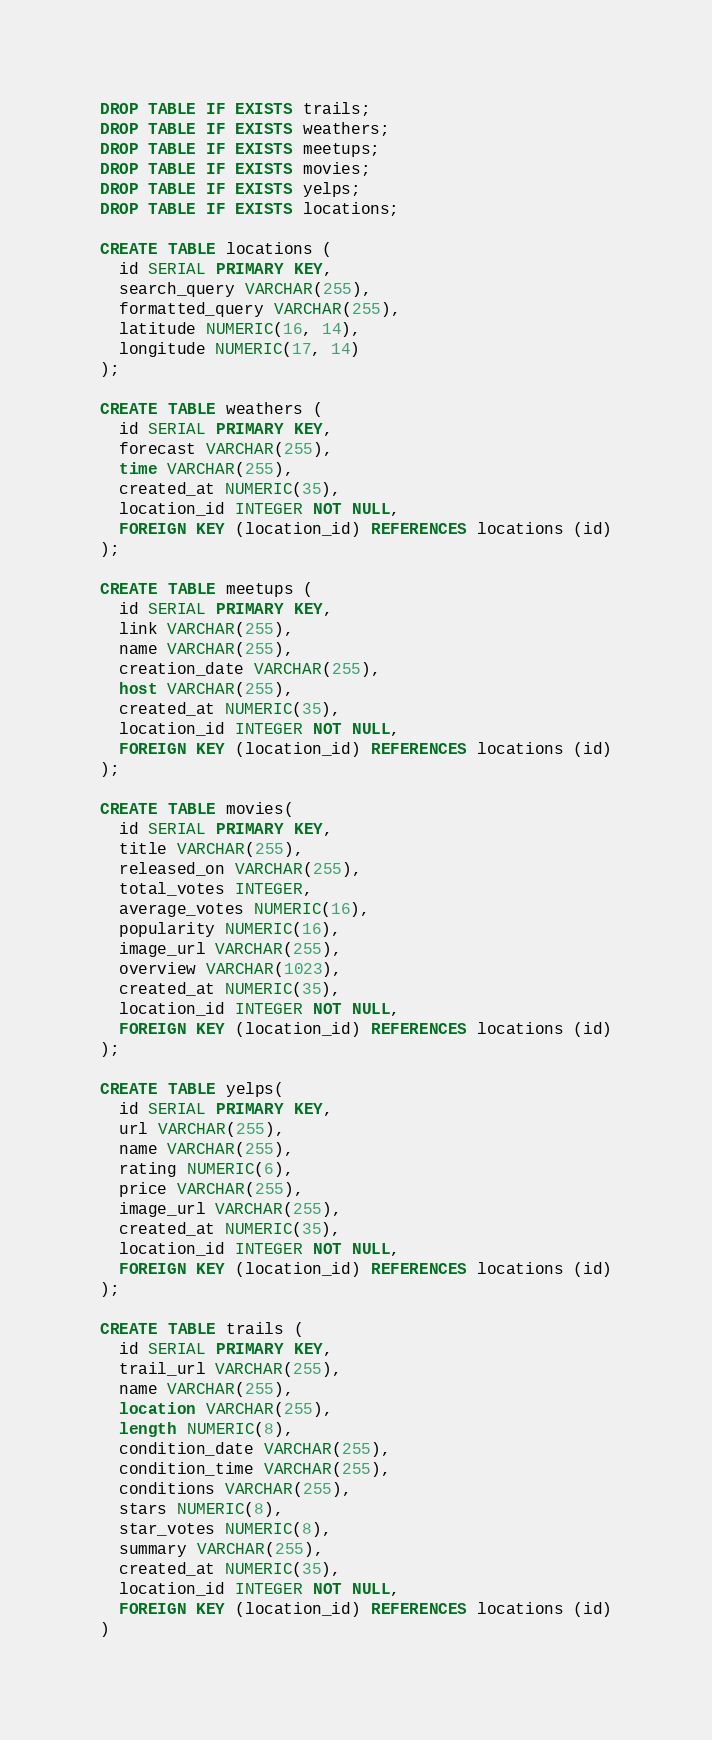Convert code to text. <code><loc_0><loc_0><loc_500><loc_500><_SQL_>DROP TABLE IF EXISTS trails;
DROP TABLE IF EXISTS weathers;
DROP TABLE IF EXISTS meetups;
DROP TABLE IF EXISTS movies;
DROP TABLE IF EXISTS yelps;
DROP TABLE IF EXISTS locations;

CREATE TABLE locations (
  id SERIAL PRIMARY KEY,
  search_query VARCHAR(255),
  formatted_query VARCHAR(255),
  latitude NUMERIC(16, 14),
  longitude NUMERIC(17, 14)
);

CREATE TABLE weathers (
  id SERIAL PRIMARY KEY,
  forecast VARCHAR(255),
  time VARCHAR(255),
  created_at NUMERIC(35),
  location_id INTEGER NOT NULL,
  FOREIGN KEY (location_id) REFERENCES locations (id)
);

CREATE TABLE meetups (
  id SERIAL PRIMARY KEY,
  link VARCHAR(255),
  name VARCHAR(255),
  creation_date VARCHAR(255),
  host VARCHAR(255),
  created_at NUMERIC(35),
  location_id INTEGER NOT NULL,
  FOREIGN KEY (location_id) REFERENCES locations (id)
);

CREATE TABLE movies(
  id SERIAL PRIMARY KEY,
  title VARCHAR(255),
  released_on VARCHAR(255),
  total_votes INTEGER,
  average_votes NUMERIC(16),
  popularity NUMERIC(16),
  image_url VARCHAR(255),
  overview VARCHAR(1023),
  created_at NUMERIC(35),
  location_id INTEGER NOT NULL,
  FOREIGN KEY (location_id) REFERENCES locations (id)
);

CREATE TABLE yelps(
  id SERIAL PRIMARY KEY,
  url VARCHAR(255),
  name VARCHAR(255),
  rating NUMERIC(6),
  price VARCHAR(255),
  image_url VARCHAR(255),
  created_at NUMERIC(35),
  location_id INTEGER NOT NULL,
  FOREIGN KEY (location_id) REFERENCES locations (id)
);

CREATE TABLE trails (
  id SERIAL PRIMARY KEY,
  trail_url VARCHAR(255),
  name VARCHAR(255),
  location VARCHAR(255),
  length NUMERIC(8),
  condition_date VARCHAR(255),
  condition_time VARCHAR(255),
  conditions VARCHAR(255),
  stars NUMERIC(8),
  star_votes NUMERIC(8),
  summary VARCHAR(255),
  created_at NUMERIC(35),
  location_id INTEGER NOT NULL,
  FOREIGN KEY (location_id) REFERENCES locations (id)
)
</code> 